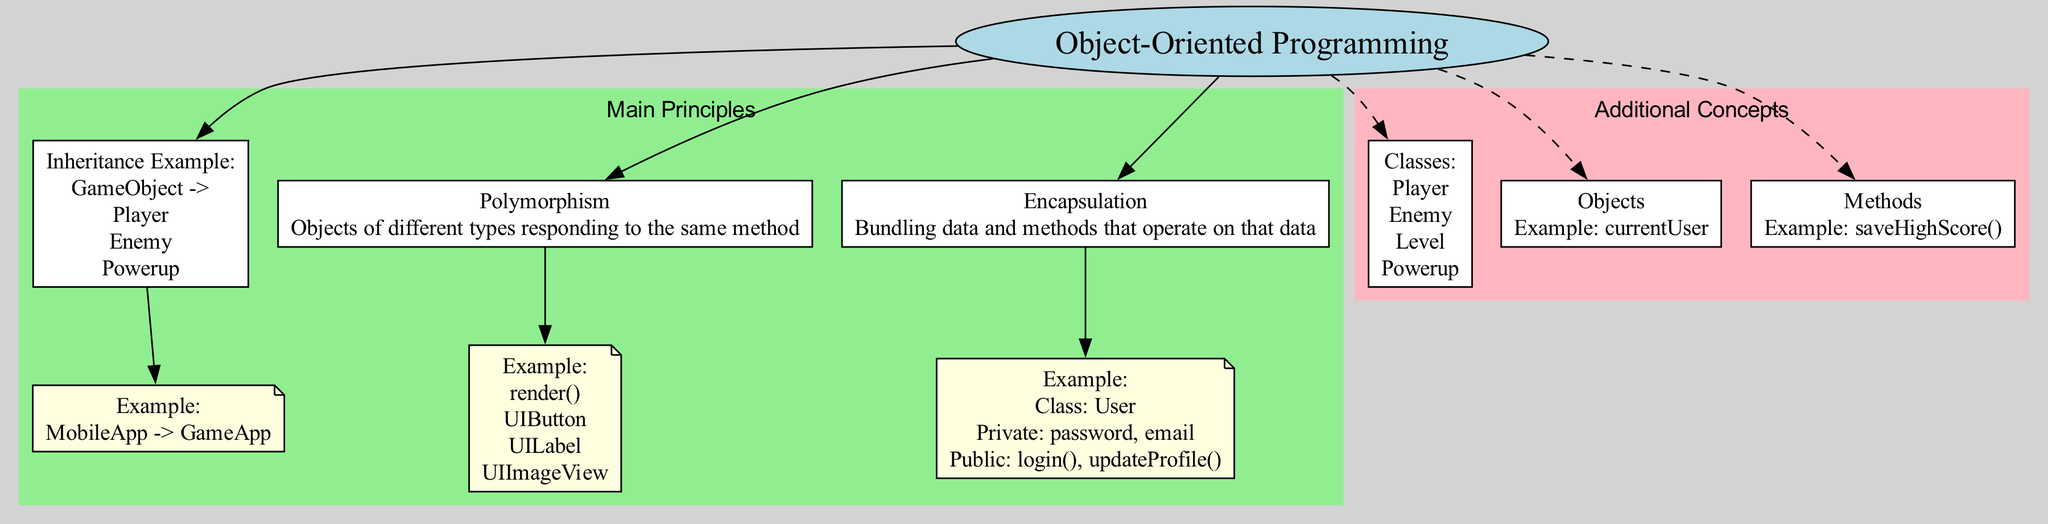What is the central concept represented in the diagram? The diagram is centered around the concept of Object-Oriented Programming, which is the foundational topic illustrated at the top.
Answer: Object-Oriented Programming How many main principles are depicted in the diagram? There are three main principles (Inheritance, Polymorphism, and Encapsulation) clearly shown in their designated section of the diagram.
Answer: Three What is an example of inheritance provided in the diagram? The inheritance example shows a relationship where the parent class MobileApp derives the child class GameApp, which can be directly read from the inheritance section.
Answer: MobileApp -> GameApp Which method is associated with polymorphism in the diagram? The method specifically mentioned under the polymorphism principle is render(), indicating that different objects can use this method in their implementation.
Answer: render() Name one of the private data attributes in the encapsulation example. The encapsulation principle provides an example class User, and one of its private data attributes listed is password, which conveys the necessary information on data protection.
Answer: password How are the classes for the real-world application of mobile game development labeled in the diagram? In the real-world application section, classes like Player, Enemy, Level, and Powerup are listed, showcasing how these elements function in mobile game development.
Answer: Player, Enemy, Level, Powerup What type of relationship is shown by the inheritance example for GameObject? The diagram illustrates that GameObject is a parent class from which children classes such as Player, Enemy, and Powerup derive, representing a clear inheritance relationship.
Answer: Parent-Child What does encapsulation bundle together? The concept of encapsulation in the diagram indicates it bundles together data (private attributes) and public methods that operate on that data, emphasizing the principle of data hiding.
Answer: Data and methods Which additional concept is illustrated with the example of AppSettings? The diagram references the concept of Classes, providing AppSettings as an example to illustrate what a class can be in object-oriented programming.
Answer: Classes 